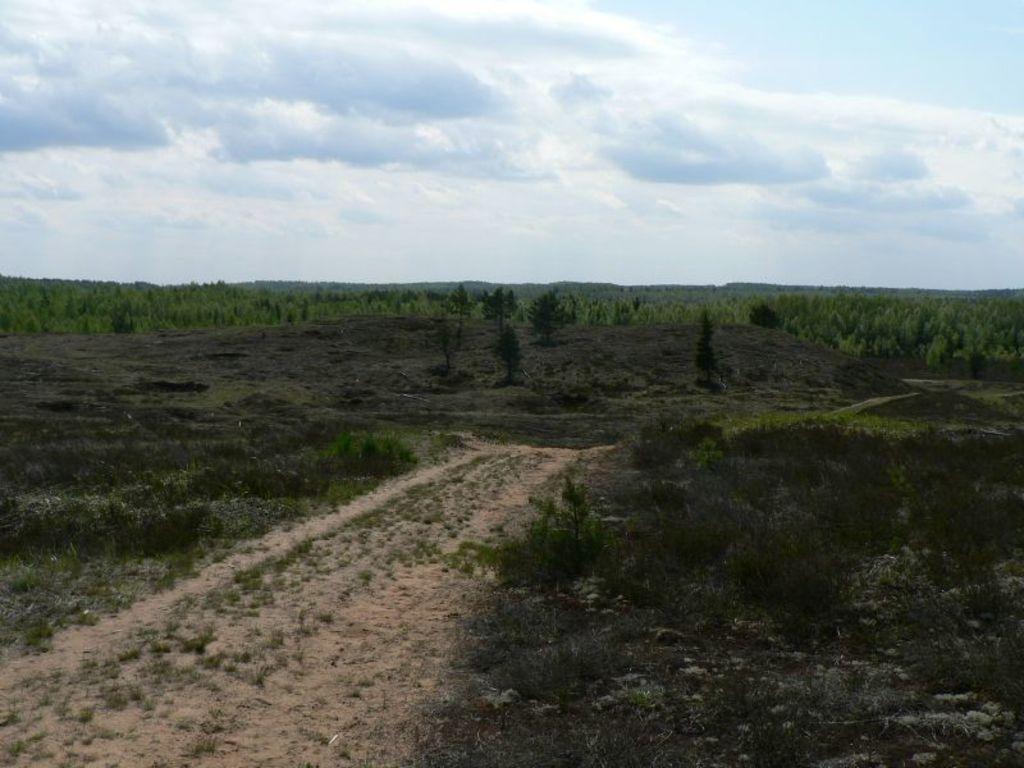Please provide a concise description of this image. In this image there is a land on which there are so many trees. At the bottom there is sand on which there is grass. At the top there is the sky. 